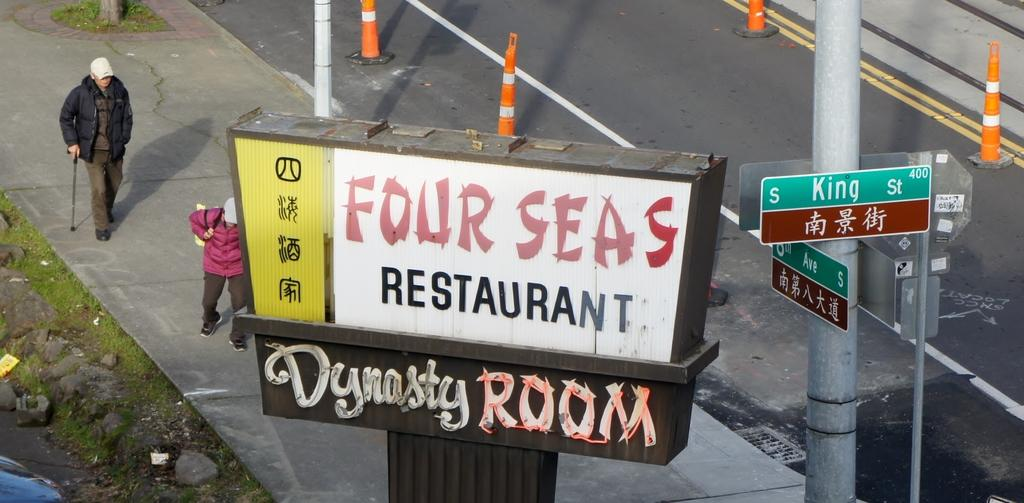<image>
Render a clear and concise summary of the photo. Man walking in front of a sign which says "Four Seas". 